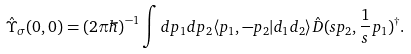Convert formula to latex. <formula><loc_0><loc_0><loc_500><loc_500>\hat { \Upsilon } _ { \, \sigma } ( 0 , 0 ) = ( 2 \pi \hbar { ) } ^ { - 1 } \int d p _ { 1 } d p _ { 2 } \langle p _ { 1 } , - p _ { 2 } | d _ { 1 } d _ { 2 } \rangle \hat { D } ( s p _ { 2 } , \frac { 1 } { s } p _ { 1 } ) ^ { \dag } .</formula> 